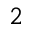<formula> <loc_0><loc_0><loc_500><loc_500>^ { 2 }</formula> 